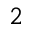<formula> <loc_0><loc_0><loc_500><loc_500>^ { 2 }</formula> 